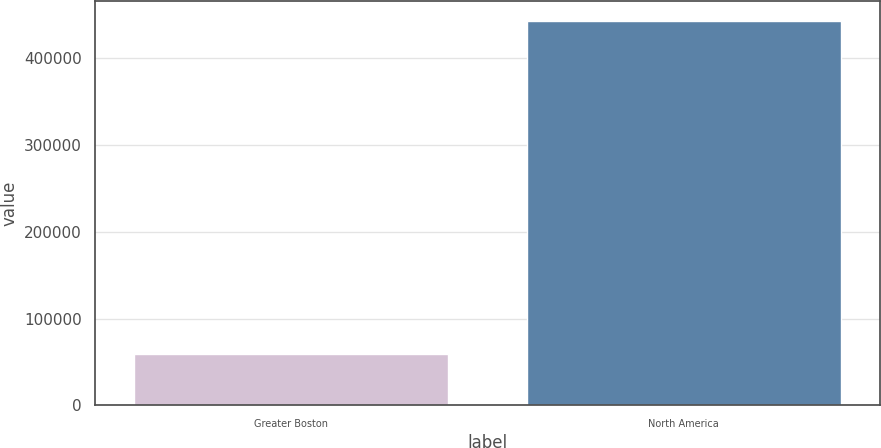Convert chart to OTSL. <chart><loc_0><loc_0><loc_500><loc_500><bar_chart><fcel>Greater Boston<fcel>North America<nl><fcel>59173<fcel>442860<nl></chart> 